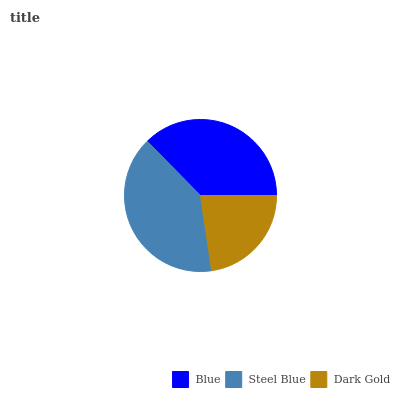Is Dark Gold the minimum?
Answer yes or no. Yes. Is Steel Blue the maximum?
Answer yes or no. Yes. Is Steel Blue the minimum?
Answer yes or no. No. Is Dark Gold the maximum?
Answer yes or no. No. Is Steel Blue greater than Dark Gold?
Answer yes or no. Yes. Is Dark Gold less than Steel Blue?
Answer yes or no. Yes. Is Dark Gold greater than Steel Blue?
Answer yes or no. No. Is Steel Blue less than Dark Gold?
Answer yes or no. No. Is Blue the high median?
Answer yes or no. Yes. Is Blue the low median?
Answer yes or no. Yes. Is Steel Blue the high median?
Answer yes or no. No. Is Dark Gold the low median?
Answer yes or no. No. 